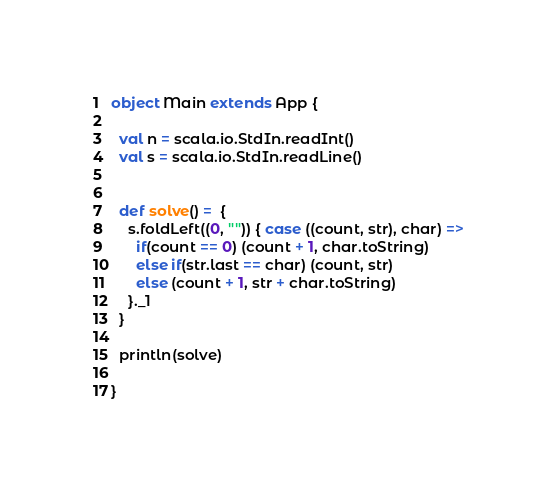<code> <loc_0><loc_0><loc_500><loc_500><_Scala_>object Main extends App {

  val n = scala.io.StdIn.readInt()
  val s = scala.io.StdIn.readLine()


  def solve() =  {
    s.foldLeft((0, "")) { case ((count, str), char) =>
      if(count == 0) (count + 1, char.toString)
      else if(str.last == char) (count, str)
      else (count + 1, str + char.toString)
    }._1
  }
  
  println(solve)

}</code> 